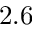Convert formula to latex. <formula><loc_0><loc_0><loc_500><loc_500>2 . 6</formula> 